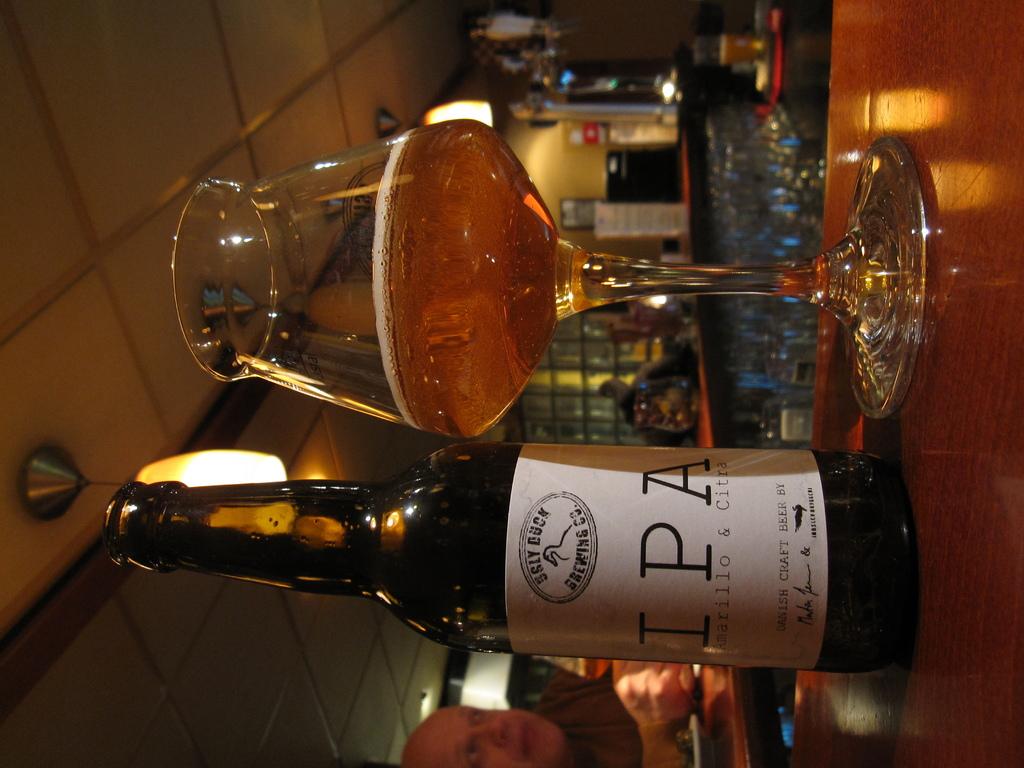What is the brewing company of this ipa?
Offer a terse response. Ugly duck. 